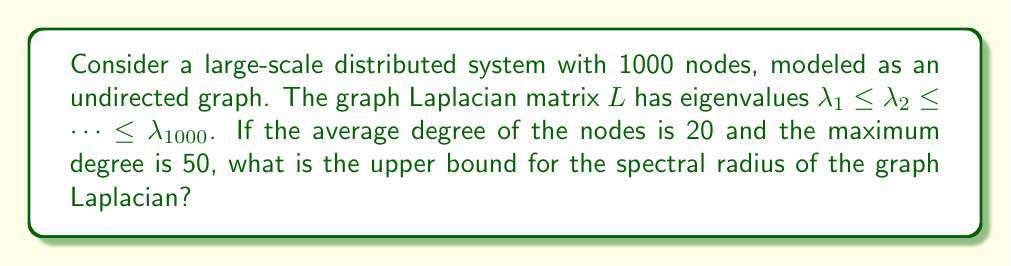Solve this math problem. Let's approach this step-by-step:

1) The spectral radius of a graph Laplacian is the largest eigenvalue, $\lambda_{1000}$ in this case.

2) For an undirected graph, the Laplacian matrix $L = D - A$, where $D$ is the degree matrix and $A$ is the adjacency matrix.

3) A well-known upper bound for the largest eigenvalue of the Laplacian is:

   $$\lambda_{max} \leq 2d_{max}$$

   where $d_{max}$ is the maximum degree in the graph.

4) In this case, we're given that the maximum degree is 50. Therefore:

   $$\lambda_{1000} \leq 2 \cdot 50 = 100$$

5) However, we can get a tighter bound using the average degree. Another bound states:

   $$\lambda_{max} \leq \max\{d_i + d_j : (i,j) \in E\}$$

   where $d_i$ and $d_j$ are degrees of adjacent vertices.

6) We don't have information about every edge, but we know the average degree is 20 and the maximum is 50. The worst case scenario for this bound would be when the maximum degree node (50) is connected to another node with degree at least as high as the average.

7) Therefore, a tighter upper bound is:

   $$\lambda_{1000} \leq 50 + 20 = 70$$

This bound is tighter than the one in step 4, so we'll use this as our final answer.
Answer: 70 